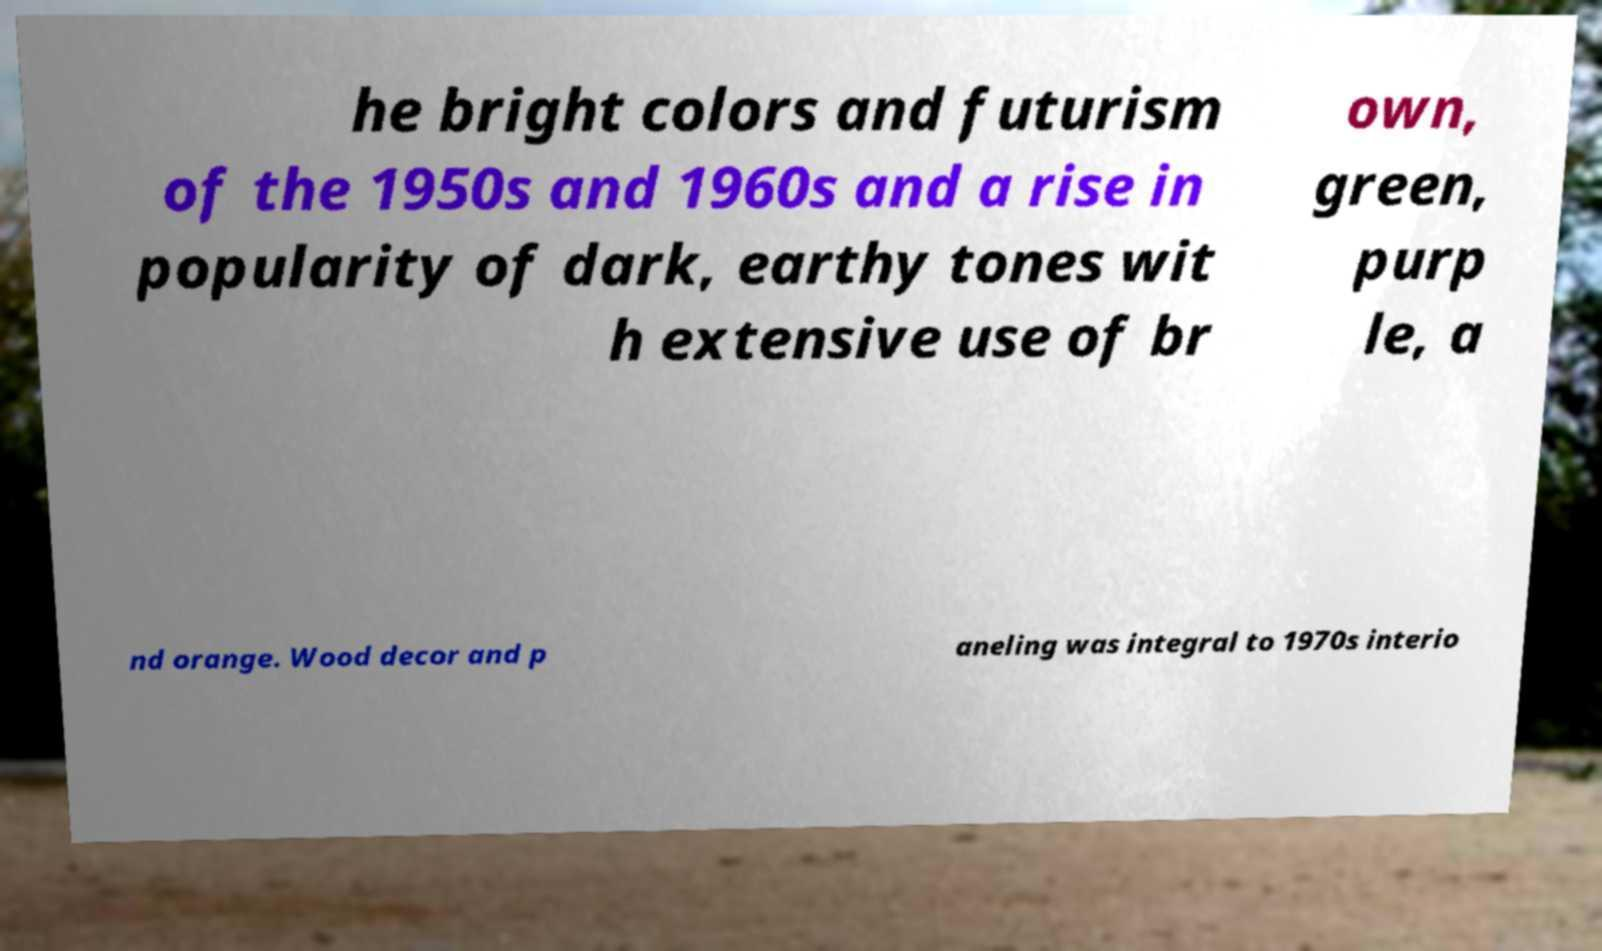Can you accurately transcribe the text from the provided image for me? he bright colors and futurism of the 1950s and 1960s and a rise in popularity of dark, earthy tones wit h extensive use of br own, green, purp le, a nd orange. Wood decor and p aneling was integral to 1970s interio 